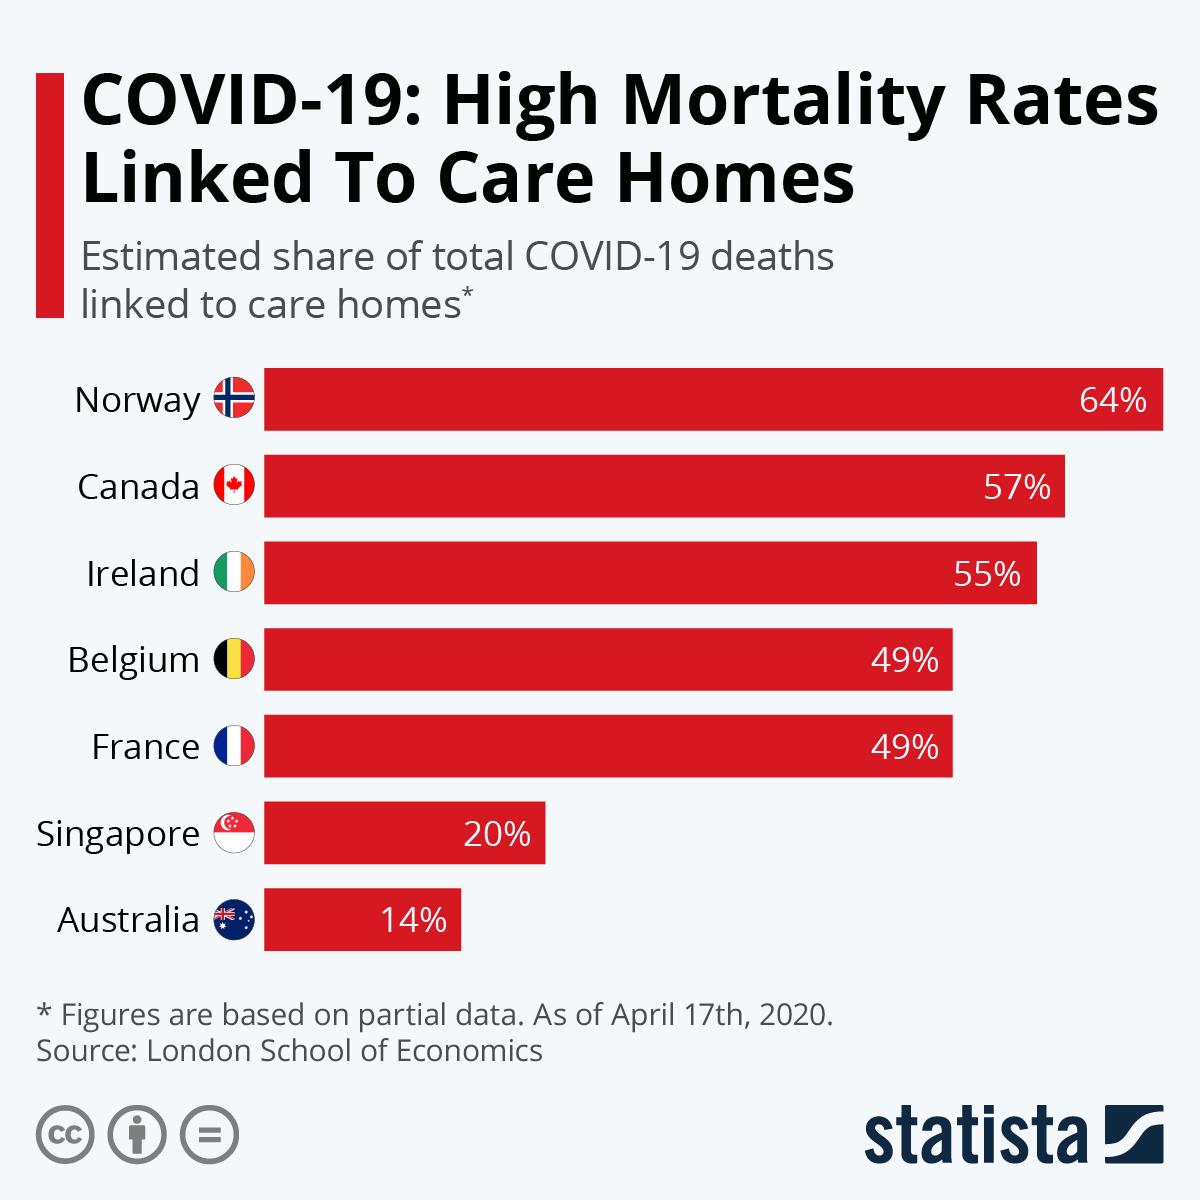Outline some significant characteristics in this image. According to the latest data available as of April 17th, 2020, it is estimated that care homes in Canada have been linked to approximately 57% of the total Covid-19 deaths. It is estimated that approximately 20% of the total Covid-19 deaths in Singapore as of April 17th, 2020 were linked to care homes. As of April 17th, 2020, it is known that Australia has the least share of total Covid-19 deaths linked to care homes. According to the latest data available as of April 17th, 2020, Norway has the highest share of total Covid-19 deaths that are linked to care homes. As of April 17th, 2020, Canada has the second highest share of total Covid-19 deaths linked to care homes. 